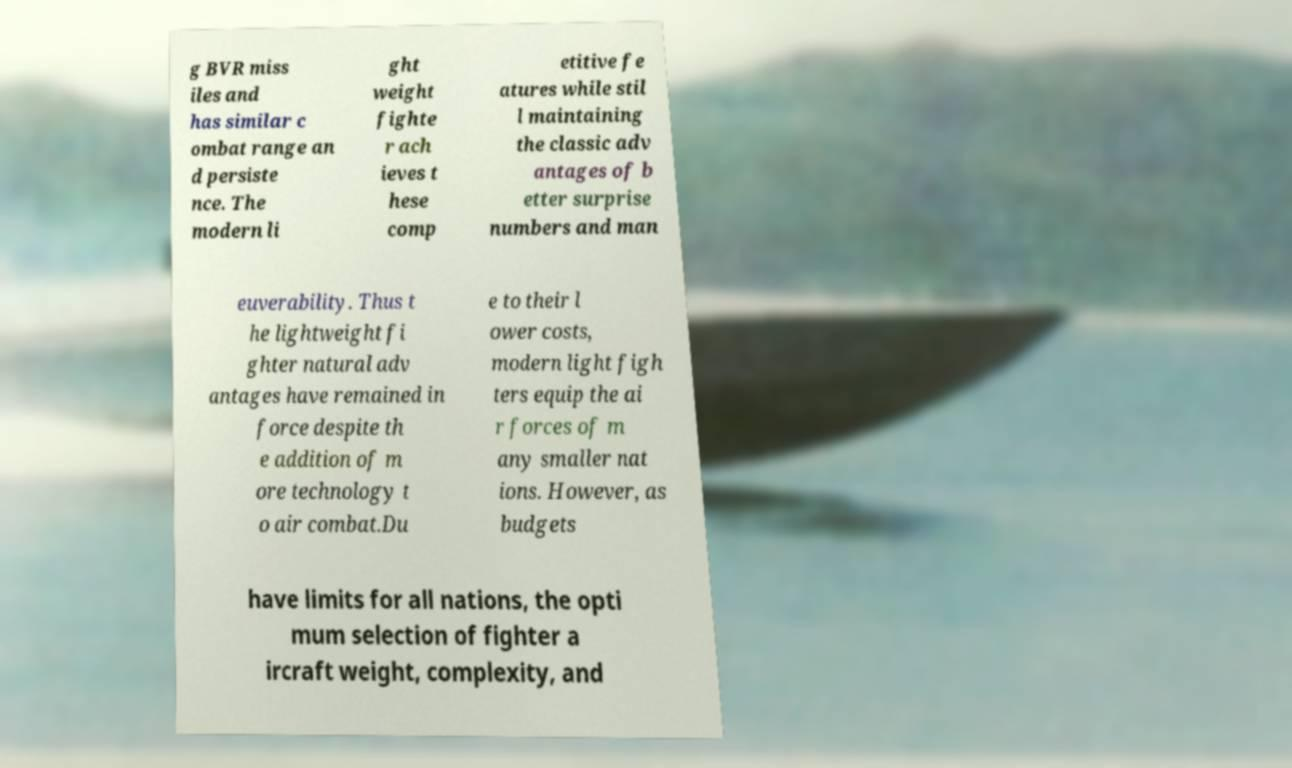Can you accurately transcribe the text from the provided image for me? g BVR miss iles and has similar c ombat range an d persiste nce. The modern li ght weight fighte r ach ieves t hese comp etitive fe atures while stil l maintaining the classic adv antages of b etter surprise numbers and man euverability. Thus t he lightweight fi ghter natural adv antages have remained in force despite th e addition of m ore technology t o air combat.Du e to their l ower costs, modern light figh ters equip the ai r forces of m any smaller nat ions. However, as budgets have limits for all nations, the opti mum selection of fighter a ircraft weight, complexity, and 